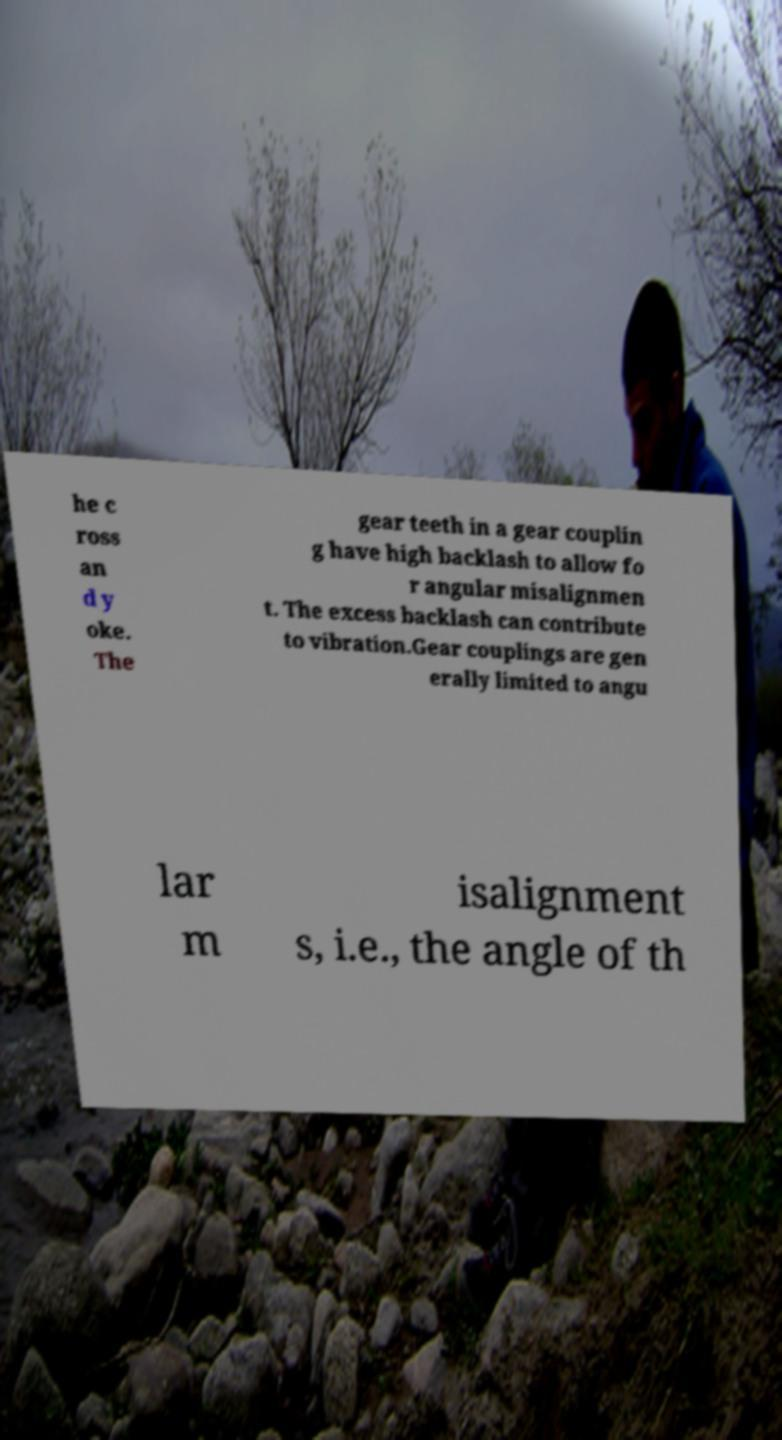I need the written content from this picture converted into text. Can you do that? he c ross an d y oke. The gear teeth in a gear couplin g have high backlash to allow fo r angular misalignmen t. The excess backlash can contribute to vibration.Gear couplings are gen erally limited to angu lar m isalignment s, i.e., the angle of th 